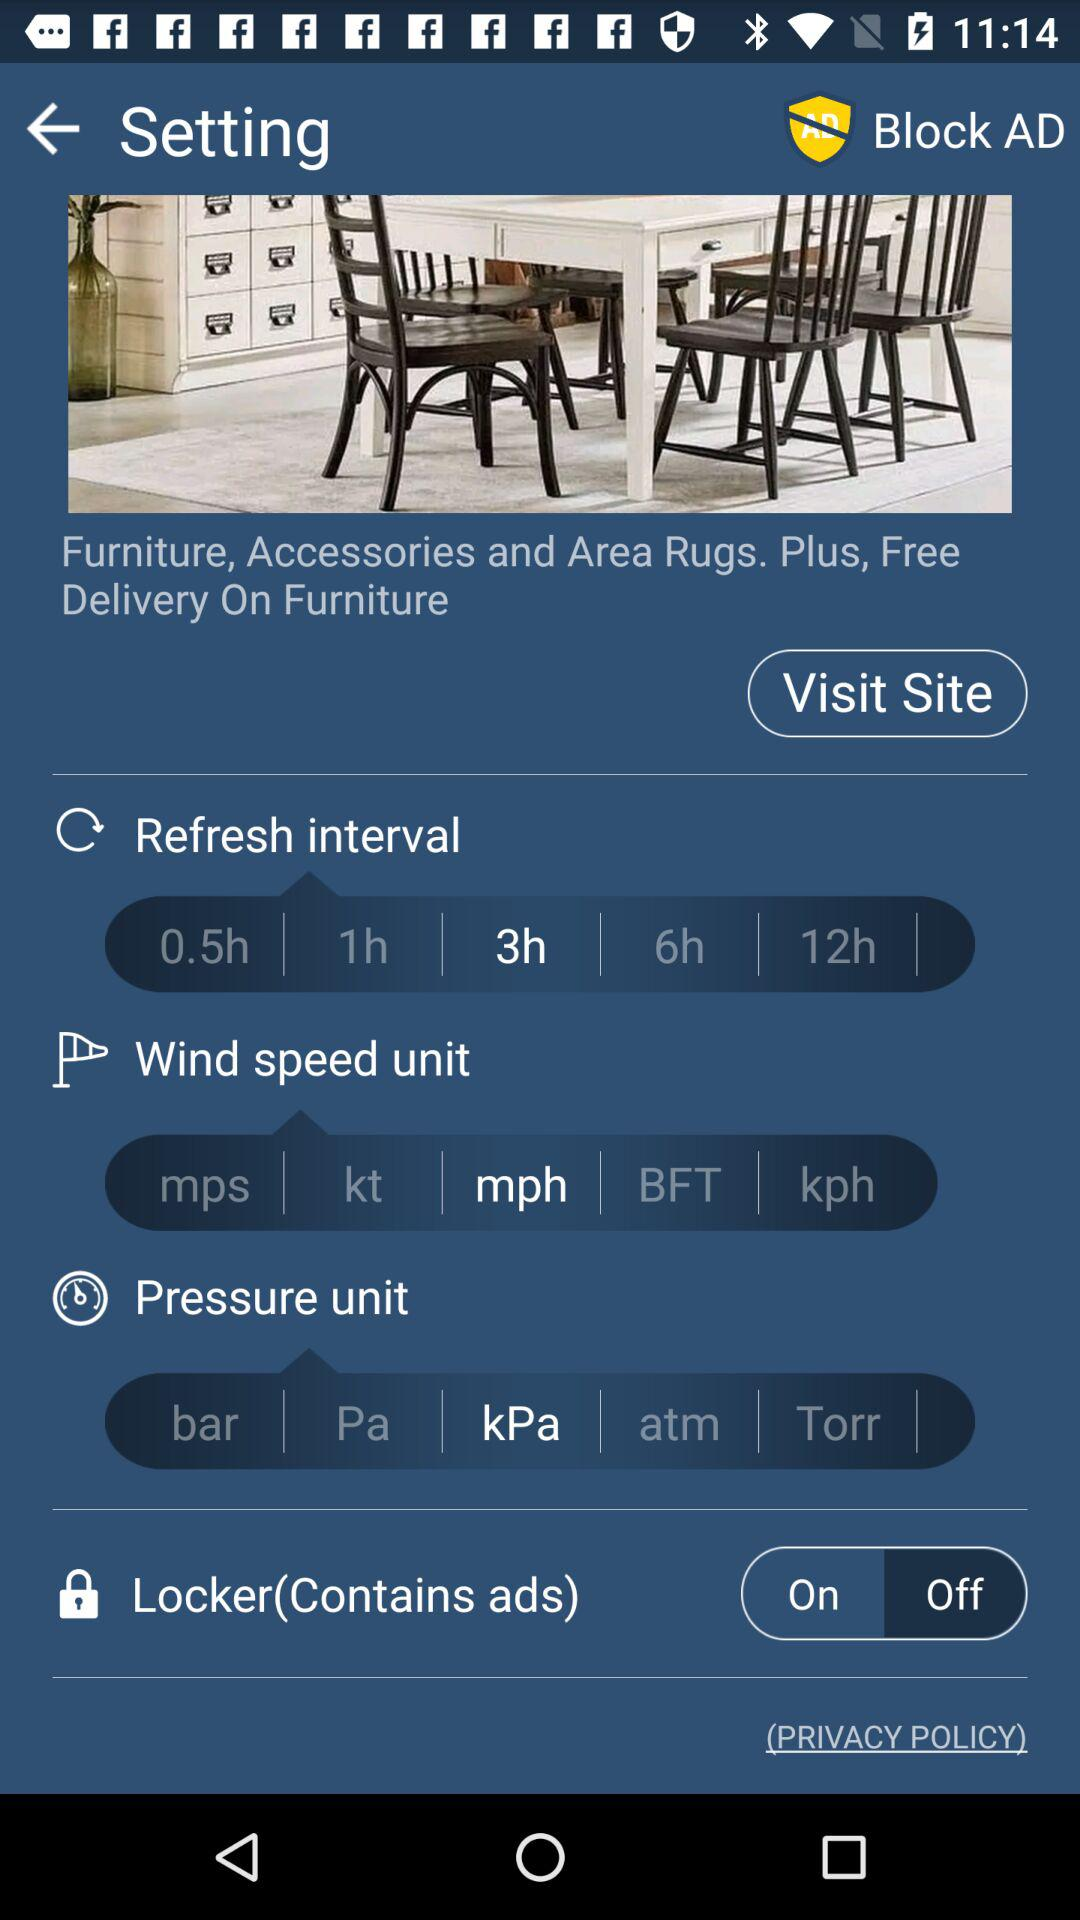What is the wind speed unit selected? The selected wind speed unit is "mph". 